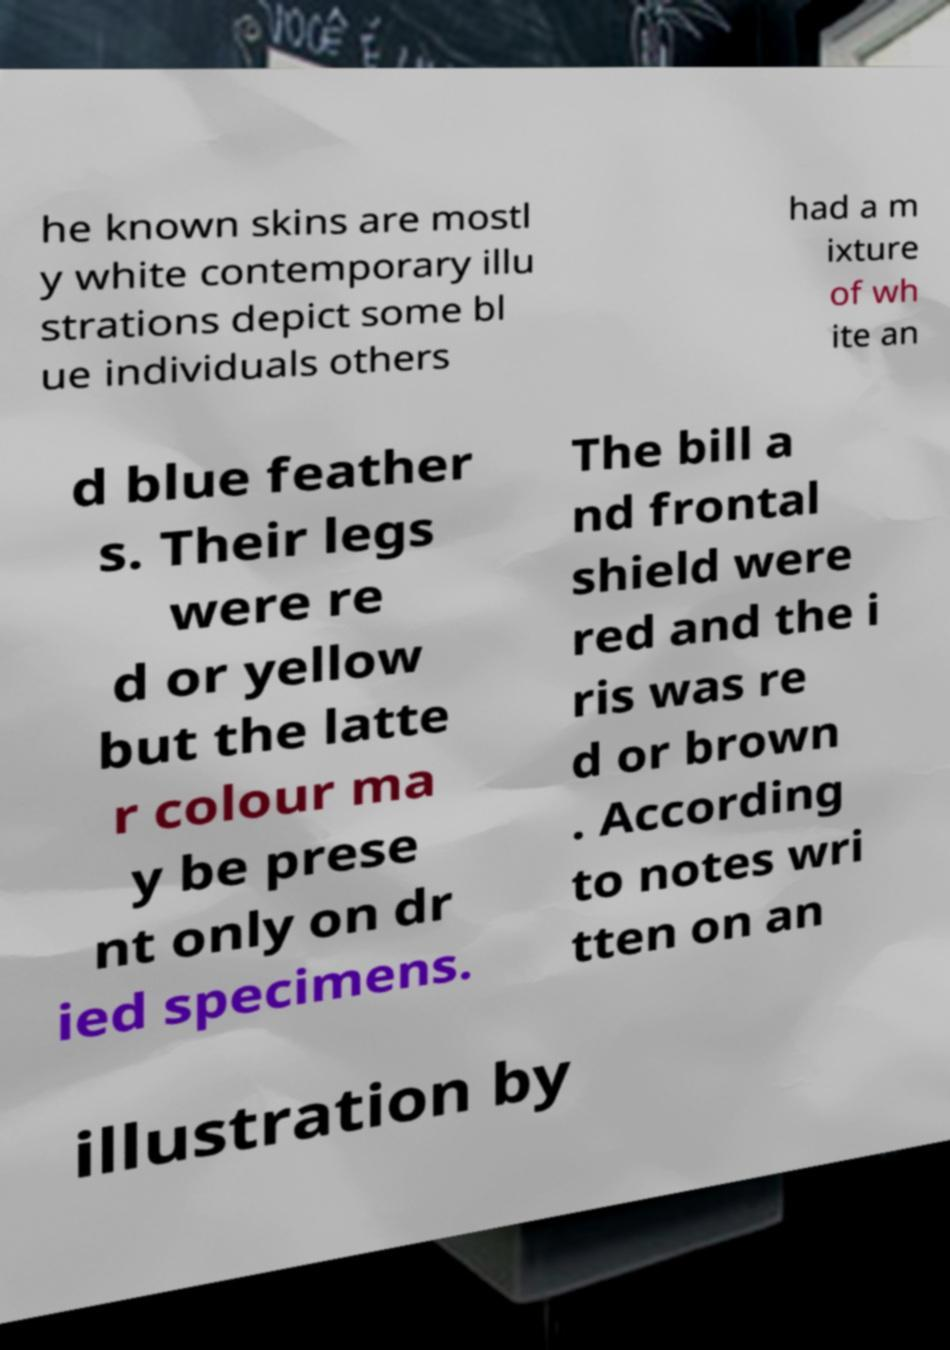For documentation purposes, I need the text within this image transcribed. Could you provide that? he known skins are mostl y white contemporary illu strations depict some bl ue individuals others had a m ixture of wh ite an d blue feather s. Their legs were re d or yellow but the latte r colour ma y be prese nt only on dr ied specimens. The bill a nd frontal shield were red and the i ris was re d or brown . According to notes wri tten on an illustration by 